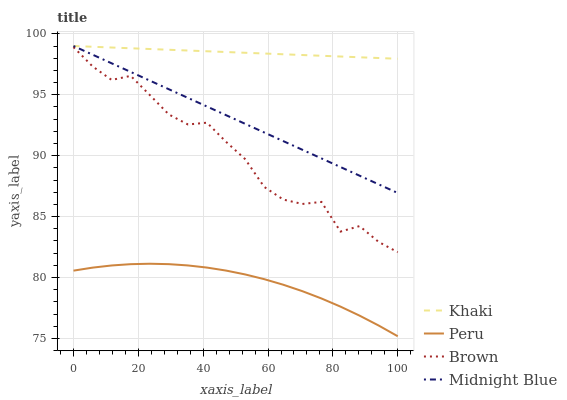Does Peru have the minimum area under the curve?
Answer yes or no. Yes. Does Khaki have the maximum area under the curve?
Answer yes or no. Yes. Does Midnight Blue have the minimum area under the curve?
Answer yes or no. No. Does Midnight Blue have the maximum area under the curve?
Answer yes or no. No. Is Khaki the smoothest?
Answer yes or no. Yes. Is Brown the roughest?
Answer yes or no. Yes. Is Midnight Blue the smoothest?
Answer yes or no. No. Is Midnight Blue the roughest?
Answer yes or no. No. Does Peru have the lowest value?
Answer yes or no. Yes. Does Midnight Blue have the lowest value?
Answer yes or no. No. Does Midnight Blue have the highest value?
Answer yes or no. Yes. Does Peru have the highest value?
Answer yes or no. No. Is Brown less than Midnight Blue?
Answer yes or no. Yes. Is Midnight Blue greater than Brown?
Answer yes or no. Yes. Does Khaki intersect Midnight Blue?
Answer yes or no. Yes. Is Khaki less than Midnight Blue?
Answer yes or no. No. Is Khaki greater than Midnight Blue?
Answer yes or no. No. Does Brown intersect Midnight Blue?
Answer yes or no. No. 